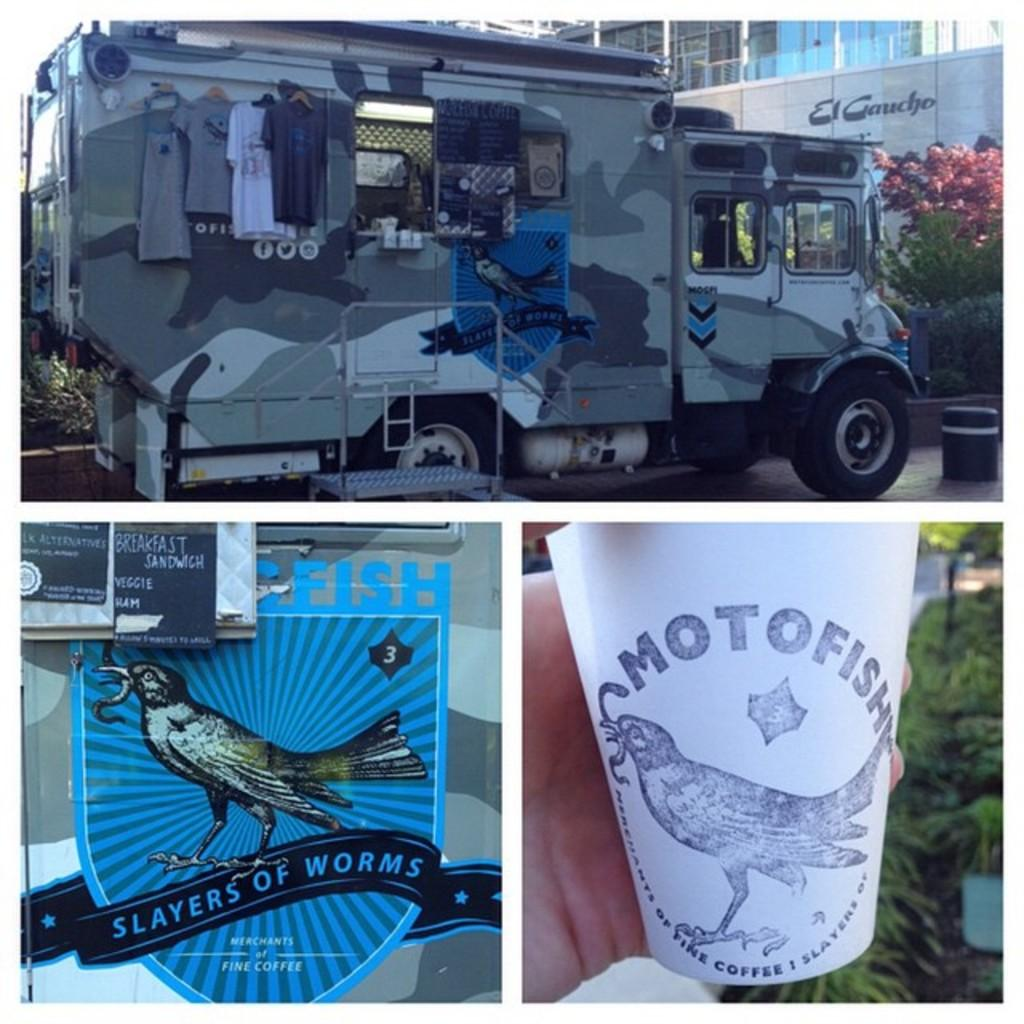<image>
Write a terse but informative summary of the picture. A collage of photos shows a vendor's van, a sticker on the van that says Slayers of Worms with a picture of a bird, and apaper cup that says Motofish. 